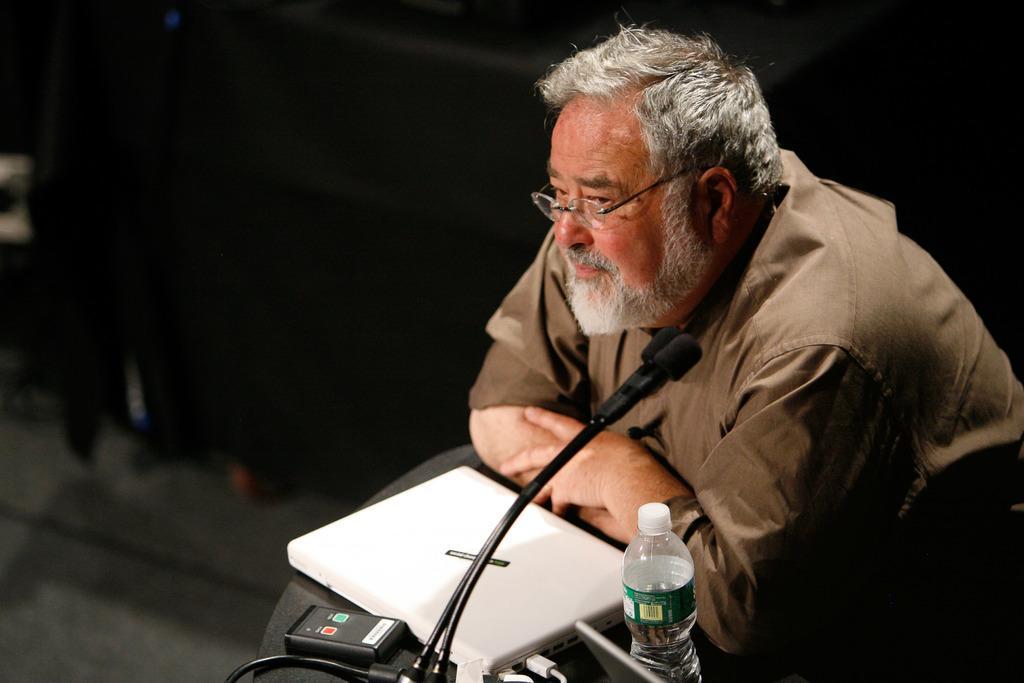Could you give a brief overview of what you see in this image? A man is standing at a podium. He wears a brown shirt and spectacles. There are laptop,mic,scanner,water bottle and other items on it. 